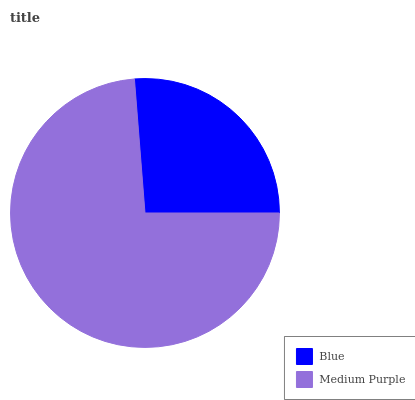Is Blue the minimum?
Answer yes or no. Yes. Is Medium Purple the maximum?
Answer yes or no. Yes. Is Medium Purple the minimum?
Answer yes or no. No. Is Medium Purple greater than Blue?
Answer yes or no. Yes. Is Blue less than Medium Purple?
Answer yes or no. Yes. Is Blue greater than Medium Purple?
Answer yes or no. No. Is Medium Purple less than Blue?
Answer yes or no. No. Is Medium Purple the high median?
Answer yes or no. Yes. Is Blue the low median?
Answer yes or no. Yes. Is Blue the high median?
Answer yes or no. No. Is Medium Purple the low median?
Answer yes or no. No. 